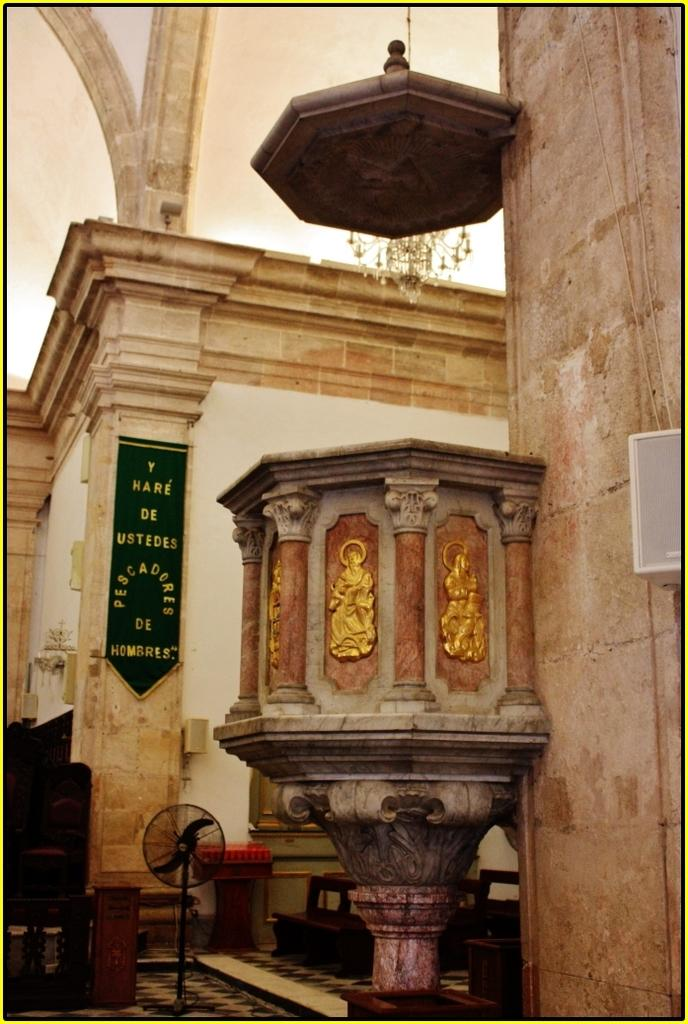What is on the wall in the image? There is a wall with carvings in the image. What other object can be seen in the image? There is a table fan in the image. What is written or depicted on the wall in the image? There is text on the wall in the image. Where is the needle used for sewing in the image? There is no needle present in the image. What type of food is being prepared on the stage in the image? There is no stage or food preparation visible in the image. 